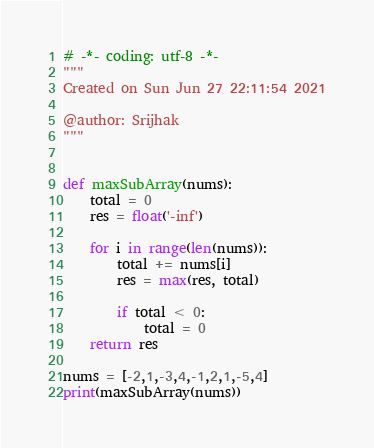Convert code to text. <code><loc_0><loc_0><loc_500><loc_500><_Python_># -*- coding: utf-8 -*-
"""
Created on Sun Jun 27 22:11:54 2021

@author: Srijhak
"""


def maxSubArray(nums):
    total = 0
    res = float('-inf')
    
    for i in range(len(nums)):
        total += nums[i]
        res = max(res, total)
        
        if total < 0:
            total = 0
    return res

nums = [-2,1,-3,4,-1,2,1,-5,4]
print(maxSubArray(nums))</code> 